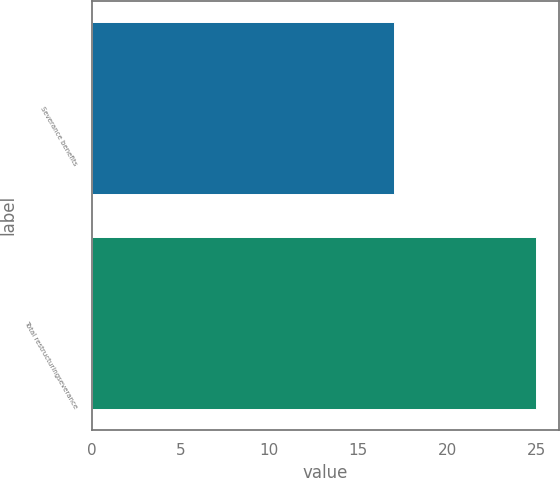Convert chart. <chart><loc_0><loc_0><loc_500><loc_500><bar_chart><fcel>Severance benefits<fcel>Total restructuringseverance<nl><fcel>17<fcel>25<nl></chart> 